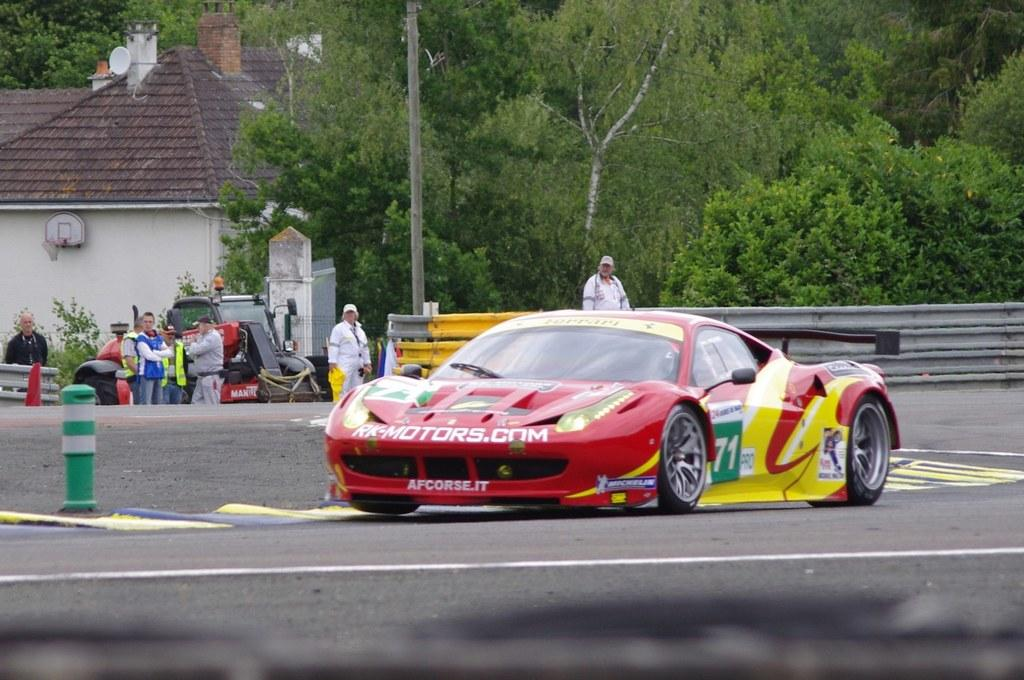What is the main subject of the image? The main subject of the image is a car. What can be seen on the road in the image? There is a pole on the road in the image. What is visible on the backside of the image? There is a vehicle, a fence, another pole, and a group of people standing on the backside in the image. What type of vegetation is visible in the image? There is a group of trees visible in the image. What type of spiders can be seen operating the distribution of goods in the image? There are no spiders or distribution of goods present in the image. What type of operation is being conducted by the group of people in the image? The image does not provide information about any operation being conducted by the group of people; they are simply standing on the backside. 